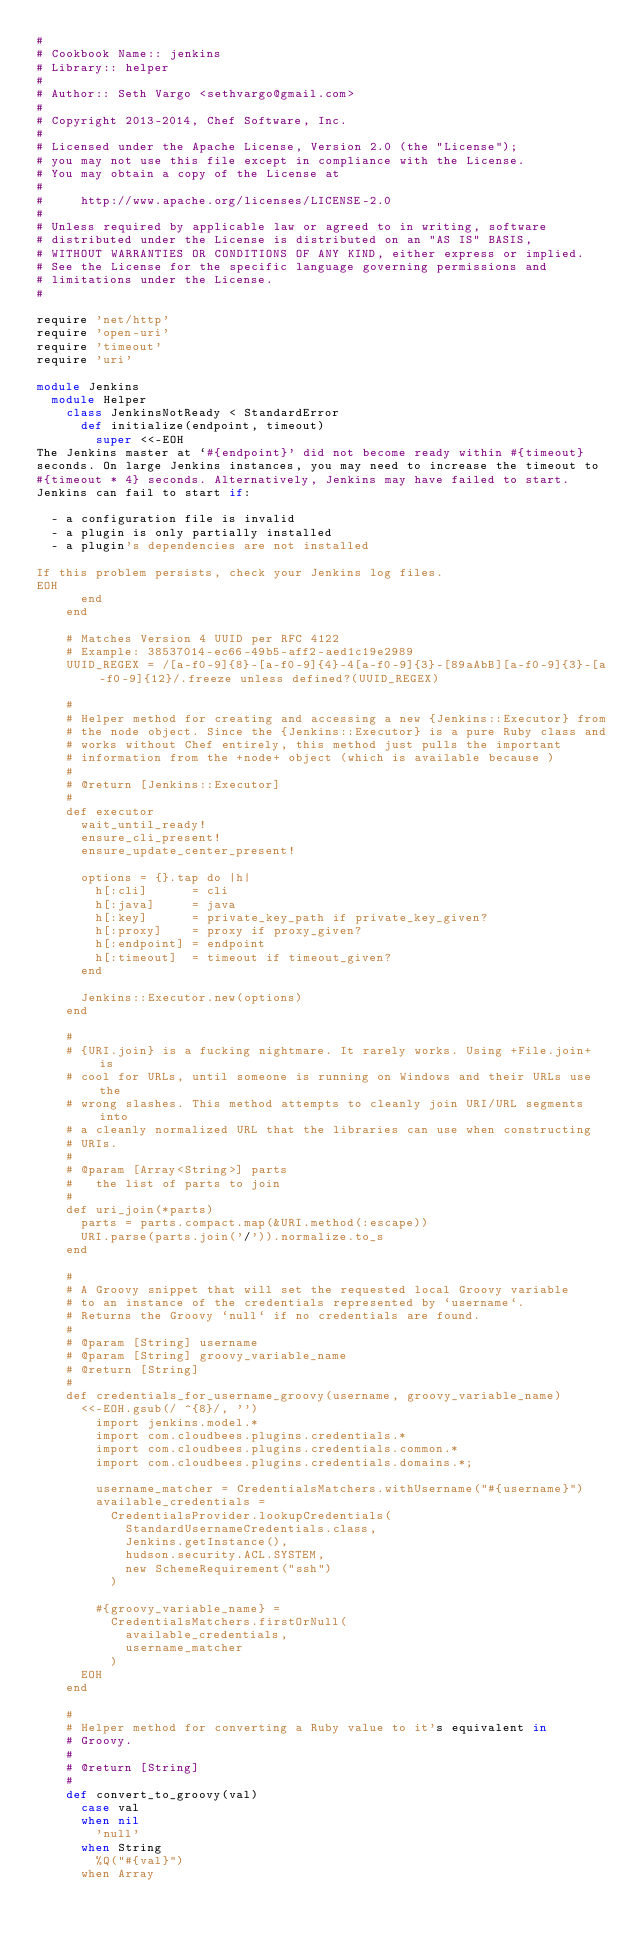Convert code to text. <code><loc_0><loc_0><loc_500><loc_500><_Ruby_>#
# Cookbook Name:: jenkins
# Library:: helper
#
# Author:: Seth Vargo <sethvargo@gmail.com>
#
# Copyright 2013-2014, Chef Software, Inc.
#
# Licensed under the Apache License, Version 2.0 (the "License");
# you may not use this file except in compliance with the License.
# You may obtain a copy of the License at
#
#     http://www.apache.org/licenses/LICENSE-2.0
#
# Unless required by applicable law or agreed to in writing, software
# distributed under the License is distributed on an "AS IS" BASIS,
# WITHOUT WARRANTIES OR CONDITIONS OF ANY KIND, either express or implied.
# See the License for the specific language governing permissions and
# limitations under the License.
#

require 'net/http'
require 'open-uri'
require 'timeout'
require 'uri'

module Jenkins
  module Helper
    class JenkinsNotReady < StandardError
      def initialize(endpoint, timeout)
        super <<-EOH
The Jenkins master at `#{endpoint}' did not become ready within #{timeout}
seconds. On large Jenkins instances, you may need to increase the timeout to
#{timeout * 4} seconds. Alternatively, Jenkins may have failed to start.
Jenkins can fail to start if:

  - a configuration file is invalid
  - a plugin is only partially installed
  - a plugin's dependencies are not installed

If this problem persists, check your Jenkins log files.
EOH
      end
    end

    # Matches Version 4 UUID per RFC 4122
    # Example: 38537014-ec66-49b5-aff2-aed1c19e2989
    UUID_REGEX = /[a-f0-9]{8}-[a-f0-9]{4}-4[a-f0-9]{3}-[89aAbB][a-f0-9]{3}-[a-f0-9]{12}/.freeze unless defined?(UUID_REGEX)

    #
    # Helper method for creating and accessing a new {Jenkins::Executor} from
    # the node object. Since the {Jenkins::Executor} is a pure Ruby class and
    # works without Chef entirely, this method just pulls the important
    # information from the +node+ object (which is available because )
    #
    # @return [Jenkins::Executor]
    #
    def executor
      wait_until_ready!
      ensure_cli_present!
      ensure_update_center_present!

      options = {}.tap do |h|
        h[:cli]      = cli
        h[:java]     = java
        h[:key]      = private_key_path if private_key_given?
        h[:proxy]    = proxy if proxy_given?
        h[:endpoint] = endpoint
        h[:timeout]  = timeout if timeout_given?
      end

      Jenkins::Executor.new(options)
    end

    #
    # {URI.join} is a fucking nightmare. It rarely works. Using +File.join+ is
    # cool for URLs, until someone is running on Windows and their URLs use the
    # wrong slashes. This method attempts to cleanly join URI/URL segments into
    # a cleanly normalized URL that the libraries can use when constructing
    # URIs.
    #
    # @param [Array<String>] parts
    #   the list of parts to join
    #
    def uri_join(*parts)
      parts = parts.compact.map(&URI.method(:escape))
      URI.parse(parts.join('/')).normalize.to_s
    end

    #
    # A Groovy snippet that will set the requested local Groovy variable
    # to an instance of the credentials represented by `username`.
    # Returns the Groovy `null` if no credentials are found.
    #
    # @param [String] username
    # @param [String] groovy_variable_name
    # @return [String]
    #
    def credentials_for_username_groovy(username, groovy_variable_name)
      <<-EOH.gsub(/ ^{8}/, '')
        import jenkins.model.*
        import com.cloudbees.plugins.credentials.*
        import com.cloudbees.plugins.credentials.common.*
        import com.cloudbees.plugins.credentials.domains.*;

        username_matcher = CredentialsMatchers.withUsername("#{username}")
        available_credentials =
          CredentialsProvider.lookupCredentials(
            StandardUsernameCredentials.class,
            Jenkins.getInstance(),
            hudson.security.ACL.SYSTEM,
            new SchemeRequirement("ssh")
          )

        #{groovy_variable_name} =
          CredentialsMatchers.firstOrNull(
            available_credentials,
            username_matcher
          )
      EOH
    end

    #
    # Helper method for converting a Ruby value to it's equivalent in
    # Groovy.
    #
    # @return [String]
    #
    def convert_to_groovy(val)
      case val
      when nil
        'null'
      when String
        %Q("#{val}")
      when Array</code> 